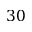<formula> <loc_0><loc_0><loc_500><loc_500>3 0</formula> 